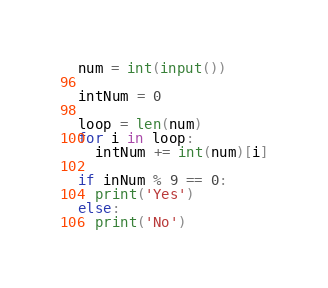<code> <loc_0><loc_0><loc_500><loc_500><_Python_>num = int(input())

intNum = 0

loop = len(num)
for i in loop:
  intNum += int(num)[i]
  
if inNum % 9 == 0:
  print('Yes')
else:
  print('No')</code> 